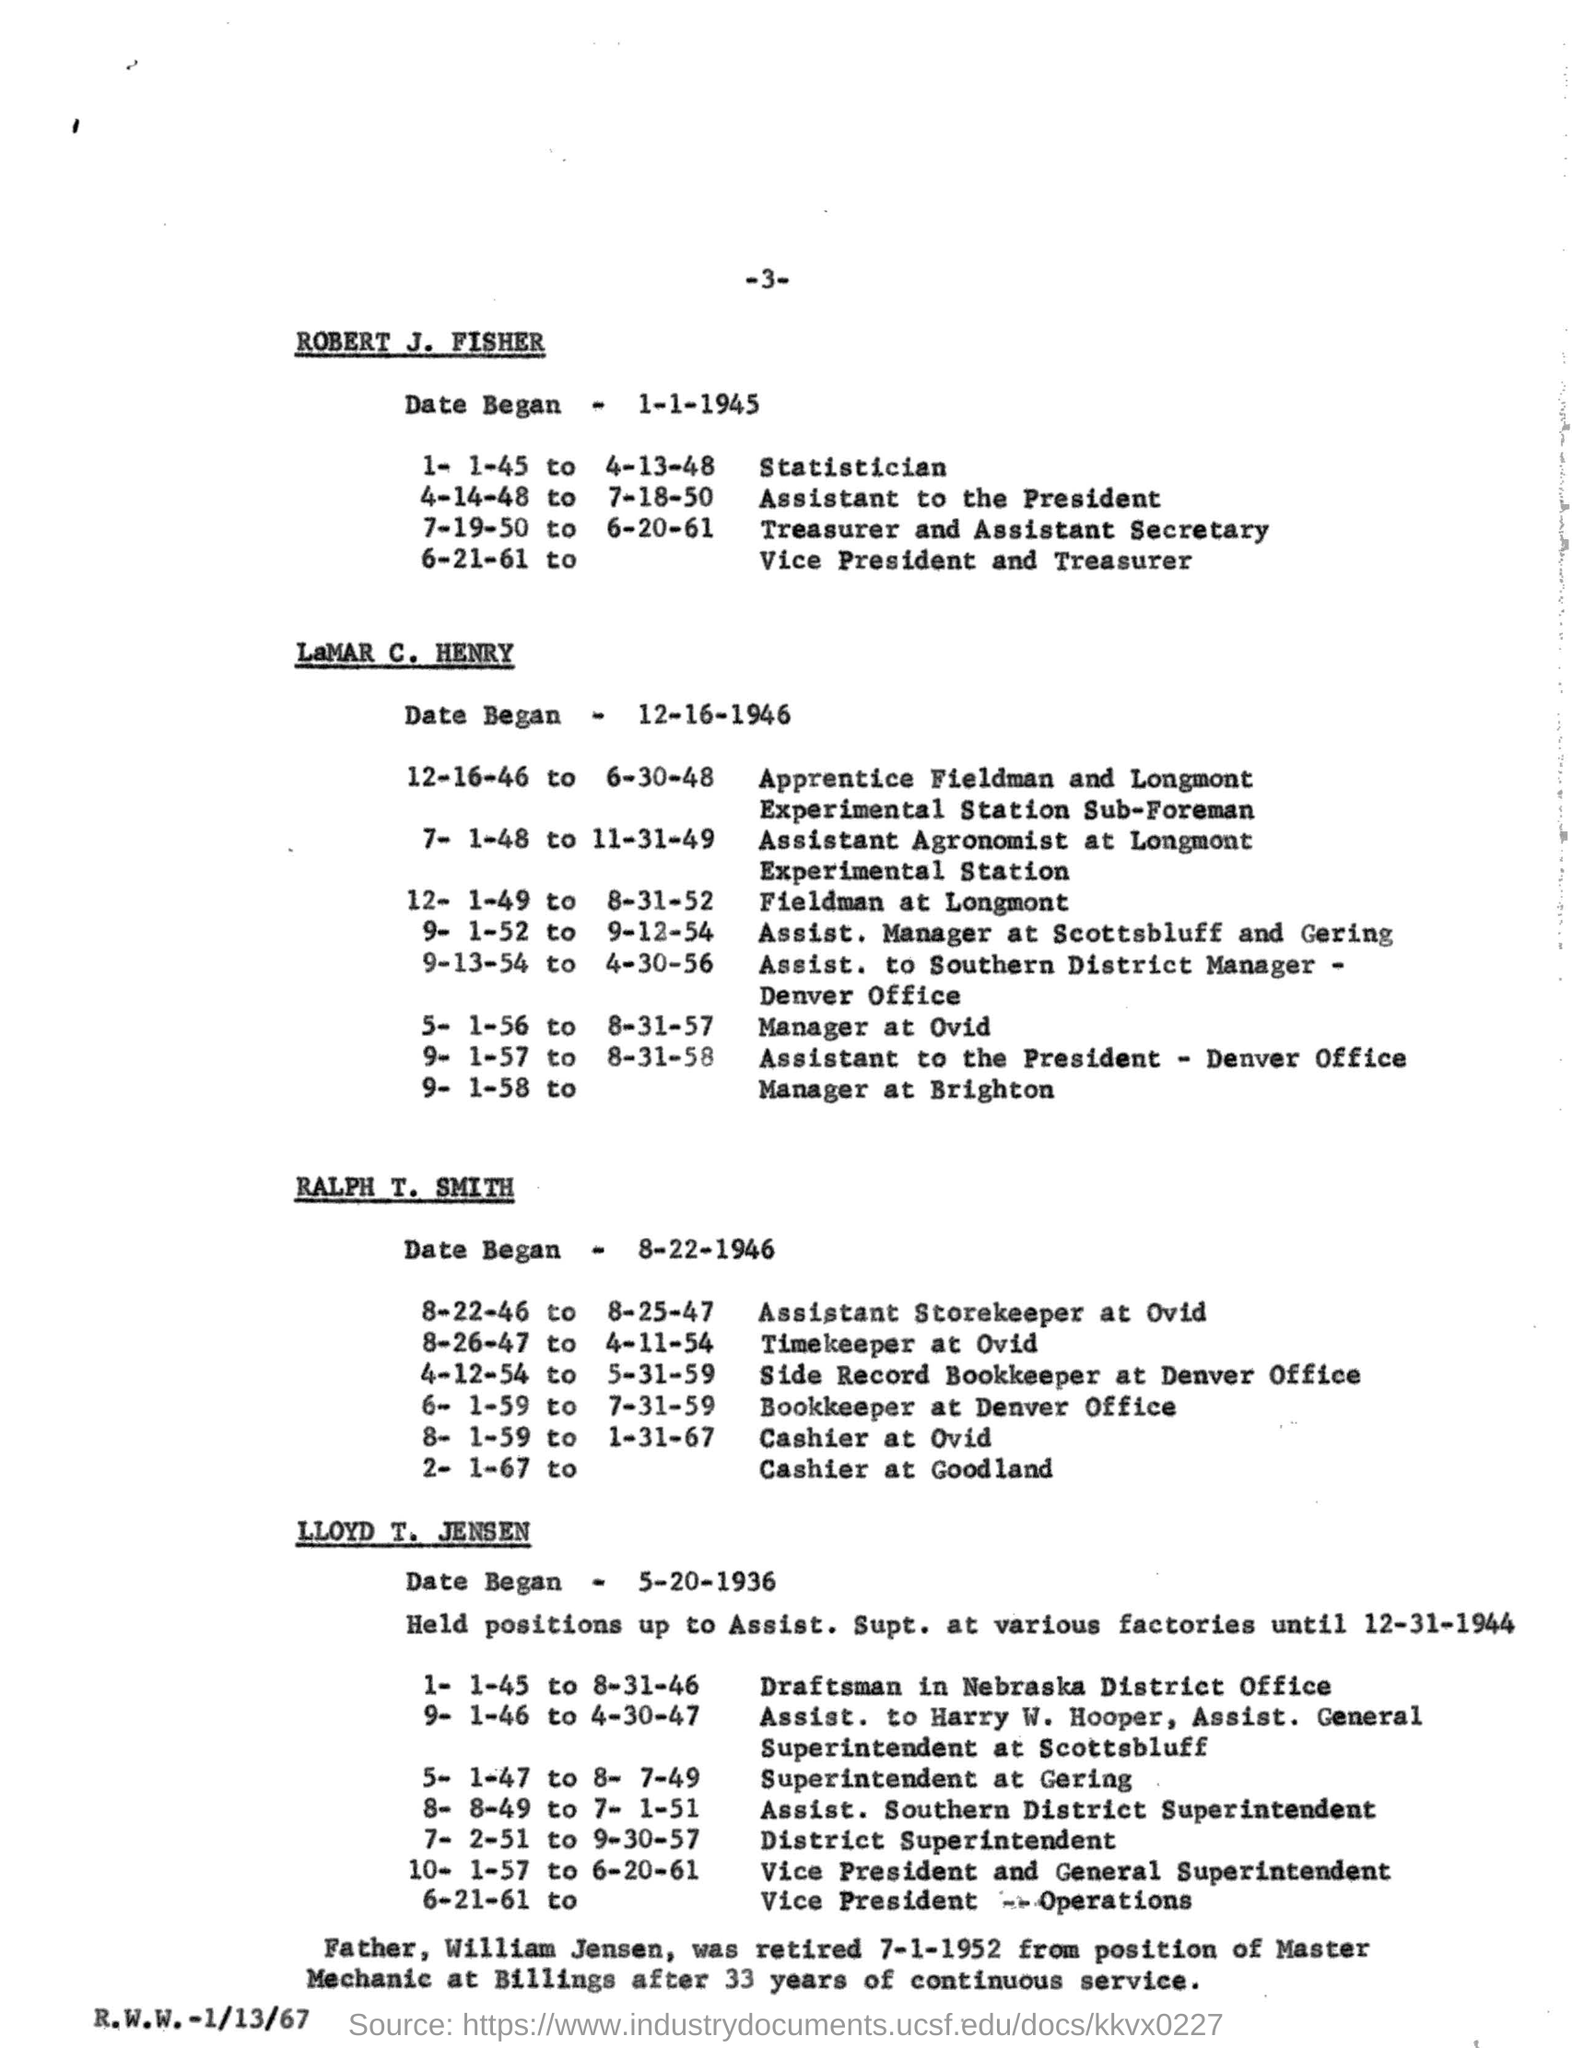What is the page number of the document?
Give a very brief answer. -3-. What is the date Began in "Rober J. Fisher"
Provide a short and direct response. 1-1-1945. 